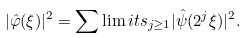<formula> <loc_0><loc_0><loc_500><loc_500>| \hat { \varphi } ( \xi ) | ^ { 2 } = \sum \lim i t s _ { j \geq 1 } | \hat { \psi } ( 2 ^ { j } \xi ) | ^ { 2 } .</formula> 